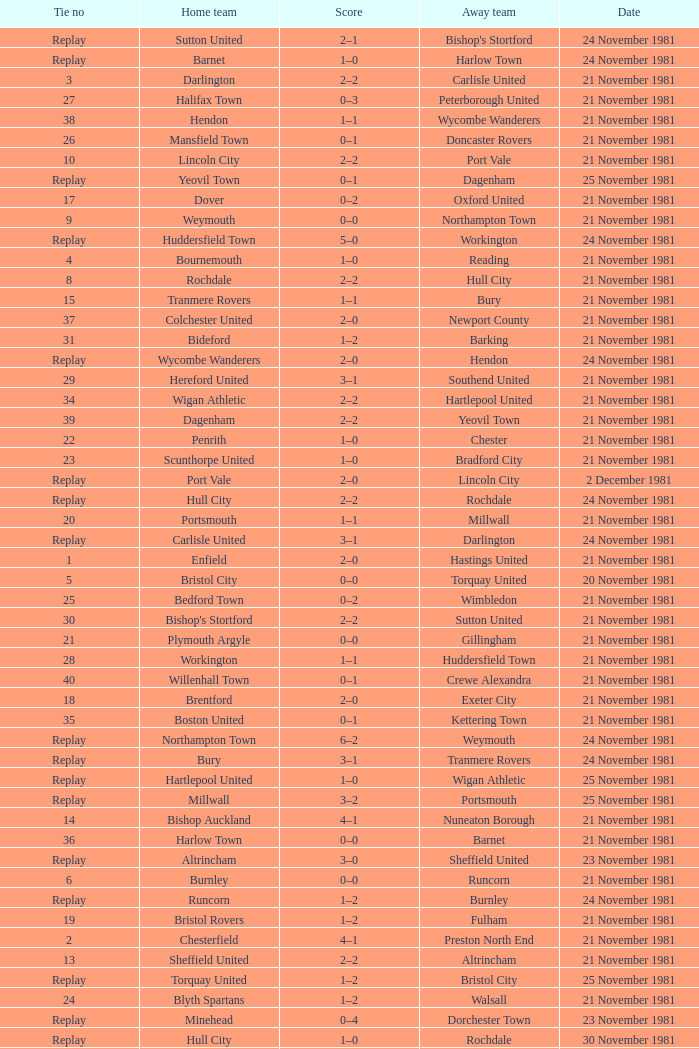Could you parse the entire table? {'header': ['Tie no', 'Home team', 'Score', 'Away team', 'Date'], 'rows': [['Replay', 'Sutton United', '2–1', "Bishop's Stortford", '24 November 1981'], ['Replay', 'Barnet', '1–0', 'Harlow Town', '24 November 1981'], ['3', 'Darlington', '2–2', 'Carlisle United', '21 November 1981'], ['27', 'Halifax Town', '0–3', 'Peterborough United', '21 November 1981'], ['38', 'Hendon', '1–1', 'Wycombe Wanderers', '21 November 1981'], ['26', 'Mansfield Town', '0–1', 'Doncaster Rovers', '21 November 1981'], ['10', 'Lincoln City', '2–2', 'Port Vale', '21 November 1981'], ['Replay', 'Yeovil Town', '0–1', 'Dagenham', '25 November 1981'], ['17', 'Dover', '0–2', 'Oxford United', '21 November 1981'], ['9', 'Weymouth', '0–0', 'Northampton Town', '21 November 1981'], ['Replay', 'Huddersfield Town', '5–0', 'Workington', '24 November 1981'], ['4', 'Bournemouth', '1–0', 'Reading', '21 November 1981'], ['8', 'Rochdale', '2–2', 'Hull City', '21 November 1981'], ['15', 'Tranmere Rovers', '1–1', 'Bury', '21 November 1981'], ['37', 'Colchester United', '2–0', 'Newport County', '21 November 1981'], ['31', 'Bideford', '1–2', 'Barking', '21 November 1981'], ['Replay', 'Wycombe Wanderers', '2–0', 'Hendon', '24 November 1981'], ['29', 'Hereford United', '3–1', 'Southend United', '21 November 1981'], ['34', 'Wigan Athletic', '2–2', 'Hartlepool United', '21 November 1981'], ['39', 'Dagenham', '2–2', 'Yeovil Town', '21 November 1981'], ['22', 'Penrith', '1–0', 'Chester', '21 November 1981'], ['23', 'Scunthorpe United', '1–0', 'Bradford City', '21 November 1981'], ['Replay', 'Port Vale', '2–0', 'Lincoln City', '2 December 1981'], ['Replay', 'Hull City', '2–2', 'Rochdale', '24 November 1981'], ['20', 'Portsmouth', '1–1', 'Millwall', '21 November 1981'], ['Replay', 'Carlisle United', '3–1', 'Darlington', '24 November 1981'], ['1', 'Enfield', '2–0', 'Hastings United', '21 November 1981'], ['5', 'Bristol City', '0–0', 'Torquay United', '20 November 1981'], ['25', 'Bedford Town', '0–2', 'Wimbledon', '21 November 1981'], ['30', "Bishop's Stortford", '2–2', 'Sutton United', '21 November 1981'], ['21', 'Plymouth Argyle', '0–0', 'Gillingham', '21 November 1981'], ['28', 'Workington', '1–1', 'Huddersfield Town', '21 November 1981'], ['40', 'Willenhall Town', '0–1', 'Crewe Alexandra', '21 November 1981'], ['18', 'Brentford', '2–0', 'Exeter City', '21 November 1981'], ['35', 'Boston United', '0–1', 'Kettering Town', '21 November 1981'], ['Replay', 'Northampton Town', '6–2', 'Weymouth', '24 November 1981'], ['Replay', 'Bury', '3–1', 'Tranmere Rovers', '24 November 1981'], ['Replay', 'Hartlepool United', '1–0', 'Wigan Athletic', '25 November 1981'], ['Replay', 'Millwall', '3–2', 'Portsmouth', '25 November 1981'], ['14', 'Bishop Auckland', '4–1', 'Nuneaton Borough', '21 November 1981'], ['36', 'Harlow Town', '0–0', 'Barnet', '21 November 1981'], ['Replay', 'Altrincham', '3–0', 'Sheffield United', '23 November 1981'], ['6', 'Burnley', '0–0', 'Runcorn', '21 November 1981'], ['Replay', 'Runcorn', '1–2', 'Burnley', '24 November 1981'], ['19', 'Bristol Rovers', '1–2', 'Fulham', '21 November 1981'], ['2', 'Chesterfield', '4–1', 'Preston North End', '21 November 1981'], ['13', 'Sheffield United', '2–2', 'Altrincham', '21 November 1981'], ['Replay', 'Torquay United', '1–2', 'Bristol City', '25 November 1981'], ['24', 'Blyth Spartans', '1–2', 'Walsall', '21 November 1981'], ['Replay', 'Minehead', '0–4', 'Dorchester Town', '23 November 1981'], ['Replay', 'Hull City', '1–0', 'Rochdale', '30 November 1981'], ['Replay', 'Port Vale', '0–0', 'Lincoln City', '30 November 1981'], ['16', 'Stockport County', '3–1', 'Mossley F.C.', '21 November 1981'], ['7', 'Dorchester Town', '3–3', 'Minehead', '21 November 1981'], ['12', 'Swindon Town', '2–1', 'Taunton Town', '21 November 1981'], ['33', 'Horden CW', '0–1', 'Blackpool', '21 November 1981'], ['32', 'Aldershot', '2–0', 'Leytonstone/Ilford', '21 November 1981'], ['Replay', 'Gillingham', '1–0', 'Plymouth Argyle', '24 November 1981'], ['11', 'Stafford Rangers', '1–2', 'York City', '21 November 1981']]} On what date was tie number 4? 21 November 1981. 